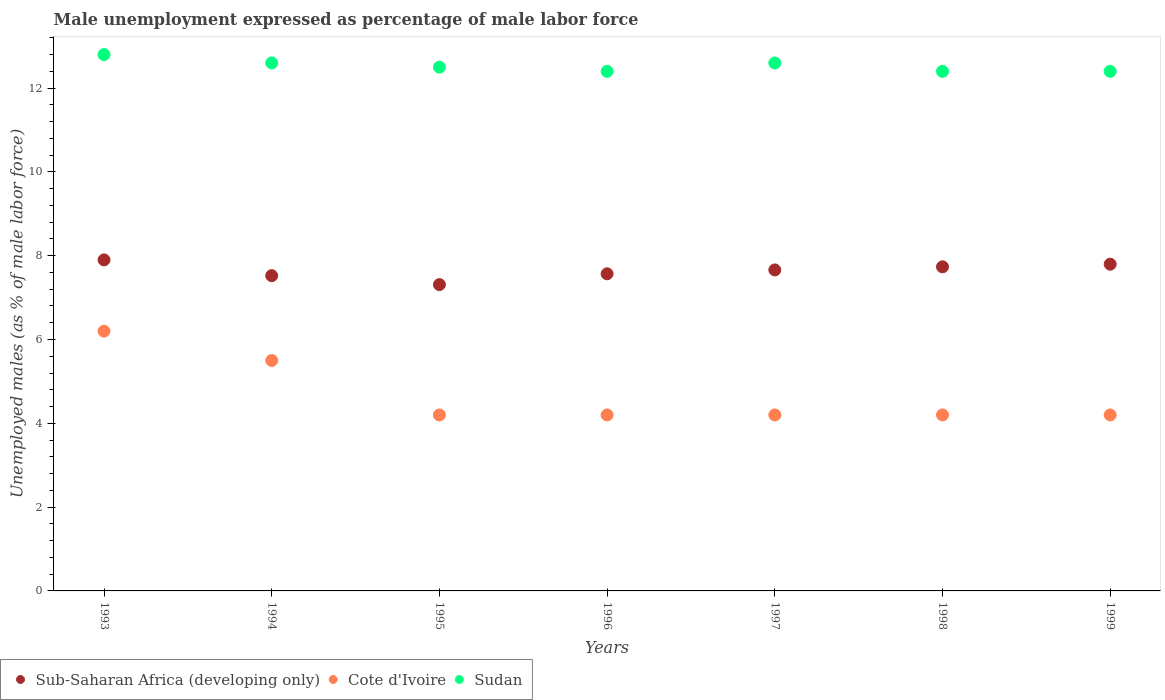Is the number of dotlines equal to the number of legend labels?
Provide a short and direct response. Yes. Across all years, what is the maximum unemployment in males in in Cote d'Ivoire?
Make the answer very short. 6.2. Across all years, what is the minimum unemployment in males in in Sudan?
Provide a short and direct response. 12.4. In which year was the unemployment in males in in Cote d'Ivoire minimum?
Provide a short and direct response. 1995. What is the total unemployment in males in in Sub-Saharan Africa (developing only) in the graph?
Offer a very short reply. 53.5. What is the difference between the unemployment in males in in Cote d'Ivoire in 1996 and that in 1999?
Your answer should be compact. 0. What is the difference between the unemployment in males in in Sudan in 1994 and the unemployment in males in in Cote d'Ivoire in 1996?
Provide a short and direct response. 8.4. What is the average unemployment in males in in Sudan per year?
Your response must be concise. 12.53. In the year 1993, what is the difference between the unemployment in males in in Sub-Saharan Africa (developing only) and unemployment in males in in Sudan?
Your response must be concise. -4.9. What is the ratio of the unemployment in males in in Cote d'Ivoire in 1994 to that in 1999?
Make the answer very short. 1.31. Is the unemployment in males in in Cote d'Ivoire in 1993 less than that in 1994?
Ensure brevity in your answer.  No. Is the difference between the unemployment in males in in Sub-Saharan Africa (developing only) in 1995 and 1999 greater than the difference between the unemployment in males in in Sudan in 1995 and 1999?
Ensure brevity in your answer.  No. What is the difference between the highest and the second highest unemployment in males in in Sudan?
Keep it short and to the point. 0.2. What is the difference between the highest and the lowest unemployment in males in in Cote d'Ivoire?
Provide a succinct answer. 2. Is it the case that in every year, the sum of the unemployment in males in in Sub-Saharan Africa (developing only) and unemployment in males in in Cote d'Ivoire  is greater than the unemployment in males in in Sudan?
Your response must be concise. No. Is the unemployment in males in in Sub-Saharan Africa (developing only) strictly less than the unemployment in males in in Sudan over the years?
Your answer should be compact. Yes. What is the difference between two consecutive major ticks on the Y-axis?
Offer a terse response. 2. Are the values on the major ticks of Y-axis written in scientific E-notation?
Your answer should be compact. No. Does the graph contain any zero values?
Make the answer very short. No. Does the graph contain grids?
Keep it short and to the point. No. How many legend labels are there?
Keep it short and to the point. 3. What is the title of the graph?
Your answer should be compact. Male unemployment expressed as percentage of male labor force. Does "Croatia" appear as one of the legend labels in the graph?
Give a very brief answer. No. What is the label or title of the Y-axis?
Your response must be concise. Unemployed males (as % of male labor force). What is the Unemployed males (as % of male labor force) in Sub-Saharan Africa (developing only) in 1993?
Keep it short and to the point. 7.9. What is the Unemployed males (as % of male labor force) of Cote d'Ivoire in 1993?
Ensure brevity in your answer.  6.2. What is the Unemployed males (as % of male labor force) in Sudan in 1993?
Keep it short and to the point. 12.8. What is the Unemployed males (as % of male labor force) of Sub-Saharan Africa (developing only) in 1994?
Provide a short and direct response. 7.52. What is the Unemployed males (as % of male labor force) of Cote d'Ivoire in 1994?
Provide a short and direct response. 5.5. What is the Unemployed males (as % of male labor force) of Sudan in 1994?
Give a very brief answer. 12.6. What is the Unemployed males (as % of male labor force) of Sub-Saharan Africa (developing only) in 1995?
Offer a very short reply. 7.31. What is the Unemployed males (as % of male labor force) in Cote d'Ivoire in 1995?
Your answer should be compact. 4.2. What is the Unemployed males (as % of male labor force) in Sudan in 1995?
Make the answer very short. 12.5. What is the Unemployed males (as % of male labor force) of Sub-Saharan Africa (developing only) in 1996?
Ensure brevity in your answer.  7.57. What is the Unemployed males (as % of male labor force) of Cote d'Ivoire in 1996?
Your response must be concise. 4.2. What is the Unemployed males (as % of male labor force) of Sudan in 1996?
Give a very brief answer. 12.4. What is the Unemployed males (as % of male labor force) of Sub-Saharan Africa (developing only) in 1997?
Make the answer very short. 7.66. What is the Unemployed males (as % of male labor force) in Cote d'Ivoire in 1997?
Your answer should be very brief. 4.2. What is the Unemployed males (as % of male labor force) in Sudan in 1997?
Your answer should be very brief. 12.6. What is the Unemployed males (as % of male labor force) in Sub-Saharan Africa (developing only) in 1998?
Your answer should be very brief. 7.74. What is the Unemployed males (as % of male labor force) in Cote d'Ivoire in 1998?
Your response must be concise. 4.2. What is the Unemployed males (as % of male labor force) in Sudan in 1998?
Your answer should be compact. 12.4. What is the Unemployed males (as % of male labor force) in Sub-Saharan Africa (developing only) in 1999?
Your answer should be very brief. 7.8. What is the Unemployed males (as % of male labor force) of Cote d'Ivoire in 1999?
Ensure brevity in your answer.  4.2. What is the Unemployed males (as % of male labor force) in Sudan in 1999?
Keep it short and to the point. 12.4. Across all years, what is the maximum Unemployed males (as % of male labor force) of Sub-Saharan Africa (developing only)?
Give a very brief answer. 7.9. Across all years, what is the maximum Unemployed males (as % of male labor force) in Cote d'Ivoire?
Offer a terse response. 6.2. Across all years, what is the maximum Unemployed males (as % of male labor force) of Sudan?
Make the answer very short. 12.8. Across all years, what is the minimum Unemployed males (as % of male labor force) in Sub-Saharan Africa (developing only)?
Give a very brief answer. 7.31. Across all years, what is the minimum Unemployed males (as % of male labor force) in Cote d'Ivoire?
Your answer should be compact. 4.2. Across all years, what is the minimum Unemployed males (as % of male labor force) in Sudan?
Offer a terse response. 12.4. What is the total Unemployed males (as % of male labor force) in Sub-Saharan Africa (developing only) in the graph?
Provide a succinct answer. 53.5. What is the total Unemployed males (as % of male labor force) in Cote d'Ivoire in the graph?
Provide a succinct answer. 32.7. What is the total Unemployed males (as % of male labor force) in Sudan in the graph?
Offer a terse response. 87.7. What is the difference between the Unemployed males (as % of male labor force) of Sub-Saharan Africa (developing only) in 1993 and that in 1994?
Make the answer very short. 0.38. What is the difference between the Unemployed males (as % of male labor force) of Sub-Saharan Africa (developing only) in 1993 and that in 1995?
Keep it short and to the point. 0.59. What is the difference between the Unemployed males (as % of male labor force) of Sub-Saharan Africa (developing only) in 1993 and that in 1996?
Give a very brief answer. 0.33. What is the difference between the Unemployed males (as % of male labor force) of Sub-Saharan Africa (developing only) in 1993 and that in 1997?
Provide a succinct answer. 0.24. What is the difference between the Unemployed males (as % of male labor force) in Cote d'Ivoire in 1993 and that in 1997?
Give a very brief answer. 2. What is the difference between the Unemployed males (as % of male labor force) of Sudan in 1993 and that in 1997?
Make the answer very short. 0.2. What is the difference between the Unemployed males (as % of male labor force) in Sub-Saharan Africa (developing only) in 1993 and that in 1998?
Provide a succinct answer. 0.17. What is the difference between the Unemployed males (as % of male labor force) of Sub-Saharan Africa (developing only) in 1993 and that in 1999?
Offer a very short reply. 0.1. What is the difference between the Unemployed males (as % of male labor force) of Cote d'Ivoire in 1993 and that in 1999?
Make the answer very short. 2. What is the difference between the Unemployed males (as % of male labor force) of Sudan in 1993 and that in 1999?
Provide a succinct answer. 0.4. What is the difference between the Unemployed males (as % of male labor force) in Sub-Saharan Africa (developing only) in 1994 and that in 1995?
Keep it short and to the point. 0.21. What is the difference between the Unemployed males (as % of male labor force) of Cote d'Ivoire in 1994 and that in 1995?
Keep it short and to the point. 1.3. What is the difference between the Unemployed males (as % of male labor force) in Sub-Saharan Africa (developing only) in 1994 and that in 1996?
Provide a succinct answer. -0.04. What is the difference between the Unemployed males (as % of male labor force) in Sudan in 1994 and that in 1996?
Provide a succinct answer. 0.2. What is the difference between the Unemployed males (as % of male labor force) in Sub-Saharan Africa (developing only) in 1994 and that in 1997?
Make the answer very short. -0.14. What is the difference between the Unemployed males (as % of male labor force) of Cote d'Ivoire in 1994 and that in 1997?
Provide a succinct answer. 1.3. What is the difference between the Unemployed males (as % of male labor force) in Sub-Saharan Africa (developing only) in 1994 and that in 1998?
Provide a short and direct response. -0.21. What is the difference between the Unemployed males (as % of male labor force) in Sudan in 1994 and that in 1998?
Your answer should be very brief. 0.2. What is the difference between the Unemployed males (as % of male labor force) in Sub-Saharan Africa (developing only) in 1994 and that in 1999?
Keep it short and to the point. -0.27. What is the difference between the Unemployed males (as % of male labor force) of Sudan in 1994 and that in 1999?
Provide a succinct answer. 0.2. What is the difference between the Unemployed males (as % of male labor force) in Sub-Saharan Africa (developing only) in 1995 and that in 1996?
Provide a succinct answer. -0.26. What is the difference between the Unemployed males (as % of male labor force) in Cote d'Ivoire in 1995 and that in 1996?
Your response must be concise. 0. What is the difference between the Unemployed males (as % of male labor force) of Sub-Saharan Africa (developing only) in 1995 and that in 1997?
Provide a succinct answer. -0.35. What is the difference between the Unemployed males (as % of male labor force) of Cote d'Ivoire in 1995 and that in 1997?
Give a very brief answer. 0. What is the difference between the Unemployed males (as % of male labor force) of Sudan in 1995 and that in 1997?
Give a very brief answer. -0.1. What is the difference between the Unemployed males (as % of male labor force) in Sub-Saharan Africa (developing only) in 1995 and that in 1998?
Offer a very short reply. -0.43. What is the difference between the Unemployed males (as % of male labor force) of Cote d'Ivoire in 1995 and that in 1998?
Offer a terse response. 0. What is the difference between the Unemployed males (as % of male labor force) of Sudan in 1995 and that in 1998?
Offer a very short reply. 0.1. What is the difference between the Unemployed males (as % of male labor force) in Sub-Saharan Africa (developing only) in 1995 and that in 1999?
Keep it short and to the point. -0.49. What is the difference between the Unemployed males (as % of male labor force) of Cote d'Ivoire in 1995 and that in 1999?
Ensure brevity in your answer.  0. What is the difference between the Unemployed males (as % of male labor force) of Sub-Saharan Africa (developing only) in 1996 and that in 1997?
Your response must be concise. -0.09. What is the difference between the Unemployed males (as % of male labor force) of Cote d'Ivoire in 1996 and that in 1997?
Provide a short and direct response. 0. What is the difference between the Unemployed males (as % of male labor force) in Sub-Saharan Africa (developing only) in 1996 and that in 1998?
Make the answer very short. -0.17. What is the difference between the Unemployed males (as % of male labor force) of Sudan in 1996 and that in 1998?
Ensure brevity in your answer.  0. What is the difference between the Unemployed males (as % of male labor force) of Sub-Saharan Africa (developing only) in 1996 and that in 1999?
Ensure brevity in your answer.  -0.23. What is the difference between the Unemployed males (as % of male labor force) of Sub-Saharan Africa (developing only) in 1997 and that in 1998?
Your answer should be compact. -0.07. What is the difference between the Unemployed males (as % of male labor force) of Sudan in 1997 and that in 1998?
Ensure brevity in your answer.  0.2. What is the difference between the Unemployed males (as % of male labor force) in Sub-Saharan Africa (developing only) in 1997 and that in 1999?
Offer a very short reply. -0.14. What is the difference between the Unemployed males (as % of male labor force) of Cote d'Ivoire in 1997 and that in 1999?
Make the answer very short. 0. What is the difference between the Unemployed males (as % of male labor force) of Sub-Saharan Africa (developing only) in 1998 and that in 1999?
Give a very brief answer. -0.06. What is the difference between the Unemployed males (as % of male labor force) in Sub-Saharan Africa (developing only) in 1993 and the Unemployed males (as % of male labor force) in Cote d'Ivoire in 1994?
Give a very brief answer. 2.4. What is the difference between the Unemployed males (as % of male labor force) of Sub-Saharan Africa (developing only) in 1993 and the Unemployed males (as % of male labor force) of Sudan in 1994?
Make the answer very short. -4.7. What is the difference between the Unemployed males (as % of male labor force) in Cote d'Ivoire in 1993 and the Unemployed males (as % of male labor force) in Sudan in 1994?
Give a very brief answer. -6.4. What is the difference between the Unemployed males (as % of male labor force) in Sub-Saharan Africa (developing only) in 1993 and the Unemployed males (as % of male labor force) in Cote d'Ivoire in 1995?
Keep it short and to the point. 3.7. What is the difference between the Unemployed males (as % of male labor force) of Sub-Saharan Africa (developing only) in 1993 and the Unemployed males (as % of male labor force) of Sudan in 1995?
Your answer should be very brief. -4.6. What is the difference between the Unemployed males (as % of male labor force) in Cote d'Ivoire in 1993 and the Unemployed males (as % of male labor force) in Sudan in 1995?
Give a very brief answer. -6.3. What is the difference between the Unemployed males (as % of male labor force) of Sub-Saharan Africa (developing only) in 1993 and the Unemployed males (as % of male labor force) of Cote d'Ivoire in 1996?
Provide a short and direct response. 3.7. What is the difference between the Unemployed males (as % of male labor force) of Sub-Saharan Africa (developing only) in 1993 and the Unemployed males (as % of male labor force) of Sudan in 1996?
Your answer should be very brief. -4.5. What is the difference between the Unemployed males (as % of male labor force) of Sub-Saharan Africa (developing only) in 1993 and the Unemployed males (as % of male labor force) of Cote d'Ivoire in 1997?
Keep it short and to the point. 3.7. What is the difference between the Unemployed males (as % of male labor force) in Sub-Saharan Africa (developing only) in 1993 and the Unemployed males (as % of male labor force) in Sudan in 1997?
Your answer should be compact. -4.7. What is the difference between the Unemployed males (as % of male labor force) of Cote d'Ivoire in 1993 and the Unemployed males (as % of male labor force) of Sudan in 1997?
Ensure brevity in your answer.  -6.4. What is the difference between the Unemployed males (as % of male labor force) in Sub-Saharan Africa (developing only) in 1993 and the Unemployed males (as % of male labor force) in Cote d'Ivoire in 1998?
Keep it short and to the point. 3.7. What is the difference between the Unemployed males (as % of male labor force) in Sub-Saharan Africa (developing only) in 1993 and the Unemployed males (as % of male labor force) in Sudan in 1998?
Your answer should be very brief. -4.5. What is the difference between the Unemployed males (as % of male labor force) of Cote d'Ivoire in 1993 and the Unemployed males (as % of male labor force) of Sudan in 1998?
Keep it short and to the point. -6.2. What is the difference between the Unemployed males (as % of male labor force) of Sub-Saharan Africa (developing only) in 1993 and the Unemployed males (as % of male labor force) of Cote d'Ivoire in 1999?
Provide a short and direct response. 3.7. What is the difference between the Unemployed males (as % of male labor force) of Sub-Saharan Africa (developing only) in 1993 and the Unemployed males (as % of male labor force) of Sudan in 1999?
Provide a short and direct response. -4.5. What is the difference between the Unemployed males (as % of male labor force) of Sub-Saharan Africa (developing only) in 1994 and the Unemployed males (as % of male labor force) of Cote d'Ivoire in 1995?
Make the answer very short. 3.32. What is the difference between the Unemployed males (as % of male labor force) in Sub-Saharan Africa (developing only) in 1994 and the Unemployed males (as % of male labor force) in Sudan in 1995?
Your response must be concise. -4.98. What is the difference between the Unemployed males (as % of male labor force) in Cote d'Ivoire in 1994 and the Unemployed males (as % of male labor force) in Sudan in 1995?
Make the answer very short. -7. What is the difference between the Unemployed males (as % of male labor force) of Sub-Saharan Africa (developing only) in 1994 and the Unemployed males (as % of male labor force) of Cote d'Ivoire in 1996?
Your answer should be compact. 3.32. What is the difference between the Unemployed males (as % of male labor force) of Sub-Saharan Africa (developing only) in 1994 and the Unemployed males (as % of male labor force) of Sudan in 1996?
Keep it short and to the point. -4.88. What is the difference between the Unemployed males (as % of male labor force) of Cote d'Ivoire in 1994 and the Unemployed males (as % of male labor force) of Sudan in 1996?
Your response must be concise. -6.9. What is the difference between the Unemployed males (as % of male labor force) of Sub-Saharan Africa (developing only) in 1994 and the Unemployed males (as % of male labor force) of Cote d'Ivoire in 1997?
Provide a short and direct response. 3.32. What is the difference between the Unemployed males (as % of male labor force) in Sub-Saharan Africa (developing only) in 1994 and the Unemployed males (as % of male labor force) in Sudan in 1997?
Your answer should be compact. -5.08. What is the difference between the Unemployed males (as % of male labor force) in Sub-Saharan Africa (developing only) in 1994 and the Unemployed males (as % of male labor force) in Cote d'Ivoire in 1998?
Provide a succinct answer. 3.32. What is the difference between the Unemployed males (as % of male labor force) in Sub-Saharan Africa (developing only) in 1994 and the Unemployed males (as % of male labor force) in Sudan in 1998?
Your answer should be very brief. -4.88. What is the difference between the Unemployed males (as % of male labor force) in Cote d'Ivoire in 1994 and the Unemployed males (as % of male labor force) in Sudan in 1998?
Your answer should be compact. -6.9. What is the difference between the Unemployed males (as % of male labor force) in Sub-Saharan Africa (developing only) in 1994 and the Unemployed males (as % of male labor force) in Cote d'Ivoire in 1999?
Offer a very short reply. 3.32. What is the difference between the Unemployed males (as % of male labor force) in Sub-Saharan Africa (developing only) in 1994 and the Unemployed males (as % of male labor force) in Sudan in 1999?
Your answer should be compact. -4.88. What is the difference between the Unemployed males (as % of male labor force) of Sub-Saharan Africa (developing only) in 1995 and the Unemployed males (as % of male labor force) of Cote d'Ivoire in 1996?
Give a very brief answer. 3.11. What is the difference between the Unemployed males (as % of male labor force) of Sub-Saharan Africa (developing only) in 1995 and the Unemployed males (as % of male labor force) of Sudan in 1996?
Offer a terse response. -5.09. What is the difference between the Unemployed males (as % of male labor force) of Sub-Saharan Africa (developing only) in 1995 and the Unemployed males (as % of male labor force) of Cote d'Ivoire in 1997?
Ensure brevity in your answer.  3.11. What is the difference between the Unemployed males (as % of male labor force) in Sub-Saharan Africa (developing only) in 1995 and the Unemployed males (as % of male labor force) in Sudan in 1997?
Keep it short and to the point. -5.29. What is the difference between the Unemployed males (as % of male labor force) of Cote d'Ivoire in 1995 and the Unemployed males (as % of male labor force) of Sudan in 1997?
Provide a short and direct response. -8.4. What is the difference between the Unemployed males (as % of male labor force) in Sub-Saharan Africa (developing only) in 1995 and the Unemployed males (as % of male labor force) in Cote d'Ivoire in 1998?
Your answer should be compact. 3.11. What is the difference between the Unemployed males (as % of male labor force) in Sub-Saharan Africa (developing only) in 1995 and the Unemployed males (as % of male labor force) in Sudan in 1998?
Your answer should be very brief. -5.09. What is the difference between the Unemployed males (as % of male labor force) in Sub-Saharan Africa (developing only) in 1995 and the Unemployed males (as % of male labor force) in Cote d'Ivoire in 1999?
Offer a terse response. 3.11. What is the difference between the Unemployed males (as % of male labor force) of Sub-Saharan Africa (developing only) in 1995 and the Unemployed males (as % of male labor force) of Sudan in 1999?
Your answer should be compact. -5.09. What is the difference between the Unemployed males (as % of male labor force) of Cote d'Ivoire in 1995 and the Unemployed males (as % of male labor force) of Sudan in 1999?
Provide a short and direct response. -8.2. What is the difference between the Unemployed males (as % of male labor force) in Sub-Saharan Africa (developing only) in 1996 and the Unemployed males (as % of male labor force) in Cote d'Ivoire in 1997?
Your response must be concise. 3.37. What is the difference between the Unemployed males (as % of male labor force) in Sub-Saharan Africa (developing only) in 1996 and the Unemployed males (as % of male labor force) in Sudan in 1997?
Give a very brief answer. -5.03. What is the difference between the Unemployed males (as % of male labor force) in Sub-Saharan Africa (developing only) in 1996 and the Unemployed males (as % of male labor force) in Cote d'Ivoire in 1998?
Offer a very short reply. 3.37. What is the difference between the Unemployed males (as % of male labor force) of Sub-Saharan Africa (developing only) in 1996 and the Unemployed males (as % of male labor force) of Sudan in 1998?
Provide a short and direct response. -4.83. What is the difference between the Unemployed males (as % of male labor force) in Sub-Saharan Africa (developing only) in 1996 and the Unemployed males (as % of male labor force) in Cote d'Ivoire in 1999?
Make the answer very short. 3.37. What is the difference between the Unemployed males (as % of male labor force) of Sub-Saharan Africa (developing only) in 1996 and the Unemployed males (as % of male labor force) of Sudan in 1999?
Offer a terse response. -4.83. What is the difference between the Unemployed males (as % of male labor force) of Sub-Saharan Africa (developing only) in 1997 and the Unemployed males (as % of male labor force) of Cote d'Ivoire in 1998?
Provide a succinct answer. 3.46. What is the difference between the Unemployed males (as % of male labor force) of Sub-Saharan Africa (developing only) in 1997 and the Unemployed males (as % of male labor force) of Sudan in 1998?
Give a very brief answer. -4.74. What is the difference between the Unemployed males (as % of male labor force) in Cote d'Ivoire in 1997 and the Unemployed males (as % of male labor force) in Sudan in 1998?
Provide a short and direct response. -8.2. What is the difference between the Unemployed males (as % of male labor force) of Sub-Saharan Africa (developing only) in 1997 and the Unemployed males (as % of male labor force) of Cote d'Ivoire in 1999?
Provide a short and direct response. 3.46. What is the difference between the Unemployed males (as % of male labor force) of Sub-Saharan Africa (developing only) in 1997 and the Unemployed males (as % of male labor force) of Sudan in 1999?
Your response must be concise. -4.74. What is the difference between the Unemployed males (as % of male labor force) in Cote d'Ivoire in 1997 and the Unemployed males (as % of male labor force) in Sudan in 1999?
Provide a succinct answer. -8.2. What is the difference between the Unemployed males (as % of male labor force) in Sub-Saharan Africa (developing only) in 1998 and the Unemployed males (as % of male labor force) in Cote d'Ivoire in 1999?
Keep it short and to the point. 3.54. What is the difference between the Unemployed males (as % of male labor force) in Sub-Saharan Africa (developing only) in 1998 and the Unemployed males (as % of male labor force) in Sudan in 1999?
Give a very brief answer. -4.66. What is the average Unemployed males (as % of male labor force) in Sub-Saharan Africa (developing only) per year?
Keep it short and to the point. 7.64. What is the average Unemployed males (as % of male labor force) in Cote d'Ivoire per year?
Provide a short and direct response. 4.67. What is the average Unemployed males (as % of male labor force) in Sudan per year?
Provide a short and direct response. 12.53. In the year 1993, what is the difference between the Unemployed males (as % of male labor force) in Sub-Saharan Africa (developing only) and Unemployed males (as % of male labor force) in Cote d'Ivoire?
Offer a very short reply. 1.7. In the year 1993, what is the difference between the Unemployed males (as % of male labor force) in Sub-Saharan Africa (developing only) and Unemployed males (as % of male labor force) in Sudan?
Keep it short and to the point. -4.9. In the year 1993, what is the difference between the Unemployed males (as % of male labor force) in Cote d'Ivoire and Unemployed males (as % of male labor force) in Sudan?
Keep it short and to the point. -6.6. In the year 1994, what is the difference between the Unemployed males (as % of male labor force) of Sub-Saharan Africa (developing only) and Unemployed males (as % of male labor force) of Cote d'Ivoire?
Give a very brief answer. 2.02. In the year 1994, what is the difference between the Unemployed males (as % of male labor force) in Sub-Saharan Africa (developing only) and Unemployed males (as % of male labor force) in Sudan?
Make the answer very short. -5.08. In the year 1995, what is the difference between the Unemployed males (as % of male labor force) in Sub-Saharan Africa (developing only) and Unemployed males (as % of male labor force) in Cote d'Ivoire?
Give a very brief answer. 3.11. In the year 1995, what is the difference between the Unemployed males (as % of male labor force) of Sub-Saharan Africa (developing only) and Unemployed males (as % of male labor force) of Sudan?
Make the answer very short. -5.19. In the year 1996, what is the difference between the Unemployed males (as % of male labor force) of Sub-Saharan Africa (developing only) and Unemployed males (as % of male labor force) of Cote d'Ivoire?
Give a very brief answer. 3.37. In the year 1996, what is the difference between the Unemployed males (as % of male labor force) in Sub-Saharan Africa (developing only) and Unemployed males (as % of male labor force) in Sudan?
Provide a short and direct response. -4.83. In the year 1996, what is the difference between the Unemployed males (as % of male labor force) of Cote d'Ivoire and Unemployed males (as % of male labor force) of Sudan?
Give a very brief answer. -8.2. In the year 1997, what is the difference between the Unemployed males (as % of male labor force) in Sub-Saharan Africa (developing only) and Unemployed males (as % of male labor force) in Cote d'Ivoire?
Offer a very short reply. 3.46. In the year 1997, what is the difference between the Unemployed males (as % of male labor force) in Sub-Saharan Africa (developing only) and Unemployed males (as % of male labor force) in Sudan?
Keep it short and to the point. -4.94. In the year 1997, what is the difference between the Unemployed males (as % of male labor force) in Cote d'Ivoire and Unemployed males (as % of male labor force) in Sudan?
Ensure brevity in your answer.  -8.4. In the year 1998, what is the difference between the Unemployed males (as % of male labor force) of Sub-Saharan Africa (developing only) and Unemployed males (as % of male labor force) of Cote d'Ivoire?
Keep it short and to the point. 3.54. In the year 1998, what is the difference between the Unemployed males (as % of male labor force) in Sub-Saharan Africa (developing only) and Unemployed males (as % of male labor force) in Sudan?
Ensure brevity in your answer.  -4.66. In the year 1999, what is the difference between the Unemployed males (as % of male labor force) in Sub-Saharan Africa (developing only) and Unemployed males (as % of male labor force) in Cote d'Ivoire?
Keep it short and to the point. 3.6. In the year 1999, what is the difference between the Unemployed males (as % of male labor force) of Sub-Saharan Africa (developing only) and Unemployed males (as % of male labor force) of Sudan?
Offer a terse response. -4.6. What is the ratio of the Unemployed males (as % of male labor force) in Sub-Saharan Africa (developing only) in 1993 to that in 1994?
Your answer should be very brief. 1.05. What is the ratio of the Unemployed males (as % of male labor force) in Cote d'Ivoire in 1993 to that in 1994?
Your response must be concise. 1.13. What is the ratio of the Unemployed males (as % of male labor force) of Sudan in 1993 to that in 1994?
Give a very brief answer. 1.02. What is the ratio of the Unemployed males (as % of male labor force) in Sub-Saharan Africa (developing only) in 1993 to that in 1995?
Provide a short and direct response. 1.08. What is the ratio of the Unemployed males (as % of male labor force) of Cote d'Ivoire in 1993 to that in 1995?
Give a very brief answer. 1.48. What is the ratio of the Unemployed males (as % of male labor force) of Sub-Saharan Africa (developing only) in 1993 to that in 1996?
Offer a very short reply. 1.04. What is the ratio of the Unemployed males (as % of male labor force) in Cote d'Ivoire in 1993 to that in 1996?
Ensure brevity in your answer.  1.48. What is the ratio of the Unemployed males (as % of male labor force) of Sudan in 1993 to that in 1996?
Your answer should be very brief. 1.03. What is the ratio of the Unemployed males (as % of male labor force) in Sub-Saharan Africa (developing only) in 1993 to that in 1997?
Your response must be concise. 1.03. What is the ratio of the Unemployed males (as % of male labor force) in Cote d'Ivoire in 1993 to that in 1997?
Your answer should be compact. 1.48. What is the ratio of the Unemployed males (as % of male labor force) in Sudan in 1993 to that in 1997?
Your answer should be very brief. 1.02. What is the ratio of the Unemployed males (as % of male labor force) in Sub-Saharan Africa (developing only) in 1993 to that in 1998?
Make the answer very short. 1.02. What is the ratio of the Unemployed males (as % of male labor force) in Cote d'Ivoire in 1993 to that in 1998?
Make the answer very short. 1.48. What is the ratio of the Unemployed males (as % of male labor force) of Sudan in 1993 to that in 1998?
Ensure brevity in your answer.  1.03. What is the ratio of the Unemployed males (as % of male labor force) in Sub-Saharan Africa (developing only) in 1993 to that in 1999?
Offer a very short reply. 1.01. What is the ratio of the Unemployed males (as % of male labor force) in Cote d'Ivoire in 1993 to that in 1999?
Offer a very short reply. 1.48. What is the ratio of the Unemployed males (as % of male labor force) of Sudan in 1993 to that in 1999?
Provide a short and direct response. 1.03. What is the ratio of the Unemployed males (as % of male labor force) in Sub-Saharan Africa (developing only) in 1994 to that in 1995?
Provide a short and direct response. 1.03. What is the ratio of the Unemployed males (as % of male labor force) in Cote d'Ivoire in 1994 to that in 1995?
Offer a very short reply. 1.31. What is the ratio of the Unemployed males (as % of male labor force) in Sudan in 1994 to that in 1995?
Provide a succinct answer. 1.01. What is the ratio of the Unemployed males (as % of male labor force) in Cote d'Ivoire in 1994 to that in 1996?
Give a very brief answer. 1.31. What is the ratio of the Unemployed males (as % of male labor force) of Sudan in 1994 to that in 1996?
Your answer should be very brief. 1.02. What is the ratio of the Unemployed males (as % of male labor force) in Sub-Saharan Africa (developing only) in 1994 to that in 1997?
Your answer should be very brief. 0.98. What is the ratio of the Unemployed males (as % of male labor force) in Cote d'Ivoire in 1994 to that in 1997?
Provide a short and direct response. 1.31. What is the ratio of the Unemployed males (as % of male labor force) in Sub-Saharan Africa (developing only) in 1994 to that in 1998?
Make the answer very short. 0.97. What is the ratio of the Unemployed males (as % of male labor force) in Cote d'Ivoire in 1994 to that in 1998?
Keep it short and to the point. 1.31. What is the ratio of the Unemployed males (as % of male labor force) of Sudan in 1994 to that in 1998?
Provide a short and direct response. 1.02. What is the ratio of the Unemployed males (as % of male labor force) of Sub-Saharan Africa (developing only) in 1994 to that in 1999?
Your answer should be compact. 0.96. What is the ratio of the Unemployed males (as % of male labor force) of Cote d'Ivoire in 1994 to that in 1999?
Keep it short and to the point. 1.31. What is the ratio of the Unemployed males (as % of male labor force) of Sudan in 1994 to that in 1999?
Provide a succinct answer. 1.02. What is the ratio of the Unemployed males (as % of male labor force) in Sub-Saharan Africa (developing only) in 1995 to that in 1996?
Make the answer very short. 0.97. What is the ratio of the Unemployed males (as % of male labor force) of Cote d'Ivoire in 1995 to that in 1996?
Give a very brief answer. 1. What is the ratio of the Unemployed males (as % of male labor force) of Sudan in 1995 to that in 1996?
Keep it short and to the point. 1.01. What is the ratio of the Unemployed males (as % of male labor force) of Sub-Saharan Africa (developing only) in 1995 to that in 1997?
Provide a succinct answer. 0.95. What is the ratio of the Unemployed males (as % of male labor force) in Sudan in 1995 to that in 1997?
Ensure brevity in your answer.  0.99. What is the ratio of the Unemployed males (as % of male labor force) in Sub-Saharan Africa (developing only) in 1995 to that in 1998?
Your answer should be very brief. 0.94. What is the ratio of the Unemployed males (as % of male labor force) of Cote d'Ivoire in 1995 to that in 1998?
Your answer should be very brief. 1. What is the ratio of the Unemployed males (as % of male labor force) of Cote d'Ivoire in 1995 to that in 1999?
Your answer should be compact. 1. What is the ratio of the Unemployed males (as % of male labor force) in Sub-Saharan Africa (developing only) in 1996 to that in 1997?
Offer a very short reply. 0.99. What is the ratio of the Unemployed males (as % of male labor force) in Sudan in 1996 to that in 1997?
Your answer should be compact. 0.98. What is the ratio of the Unemployed males (as % of male labor force) in Sub-Saharan Africa (developing only) in 1996 to that in 1998?
Give a very brief answer. 0.98. What is the ratio of the Unemployed males (as % of male labor force) of Sub-Saharan Africa (developing only) in 1996 to that in 1999?
Offer a very short reply. 0.97. What is the ratio of the Unemployed males (as % of male labor force) in Sudan in 1996 to that in 1999?
Provide a succinct answer. 1. What is the ratio of the Unemployed males (as % of male labor force) in Cote d'Ivoire in 1997 to that in 1998?
Give a very brief answer. 1. What is the ratio of the Unemployed males (as % of male labor force) in Sudan in 1997 to that in 1998?
Your answer should be very brief. 1.02. What is the ratio of the Unemployed males (as % of male labor force) in Sub-Saharan Africa (developing only) in 1997 to that in 1999?
Your answer should be compact. 0.98. What is the ratio of the Unemployed males (as % of male labor force) of Cote d'Ivoire in 1997 to that in 1999?
Make the answer very short. 1. What is the ratio of the Unemployed males (as % of male labor force) of Sudan in 1997 to that in 1999?
Offer a terse response. 1.02. What is the ratio of the Unemployed males (as % of male labor force) of Cote d'Ivoire in 1998 to that in 1999?
Make the answer very short. 1. What is the ratio of the Unemployed males (as % of male labor force) in Sudan in 1998 to that in 1999?
Keep it short and to the point. 1. What is the difference between the highest and the second highest Unemployed males (as % of male labor force) in Sub-Saharan Africa (developing only)?
Your response must be concise. 0.1. What is the difference between the highest and the lowest Unemployed males (as % of male labor force) of Sub-Saharan Africa (developing only)?
Offer a terse response. 0.59. 